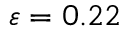<formula> <loc_0><loc_0><loc_500><loc_500>\varepsilon = 0 . 2 2</formula> 